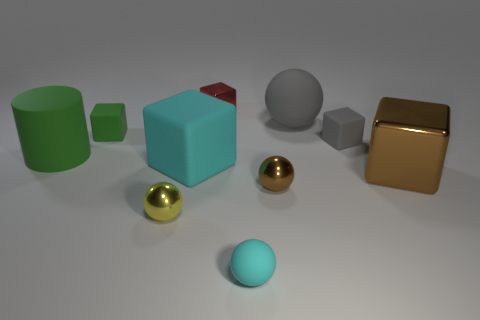Subtract all big balls. How many balls are left? 3 Subtract all brown spheres. How many spheres are left? 3 Subtract 3 spheres. How many spheres are left? 1 Subtract all brown cubes. Subtract all yellow balls. How many cubes are left? 4 Subtract all blue cylinders. How many red cubes are left? 1 Subtract all tiny rubber objects. Subtract all small cyan rubber things. How many objects are left? 6 Add 2 brown balls. How many brown balls are left? 3 Add 9 green cylinders. How many green cylinders exist? 10 Subtract 0 gray cylinders. How many objects are left? 10 Subtract all cylinders. How many objects are left? 9 